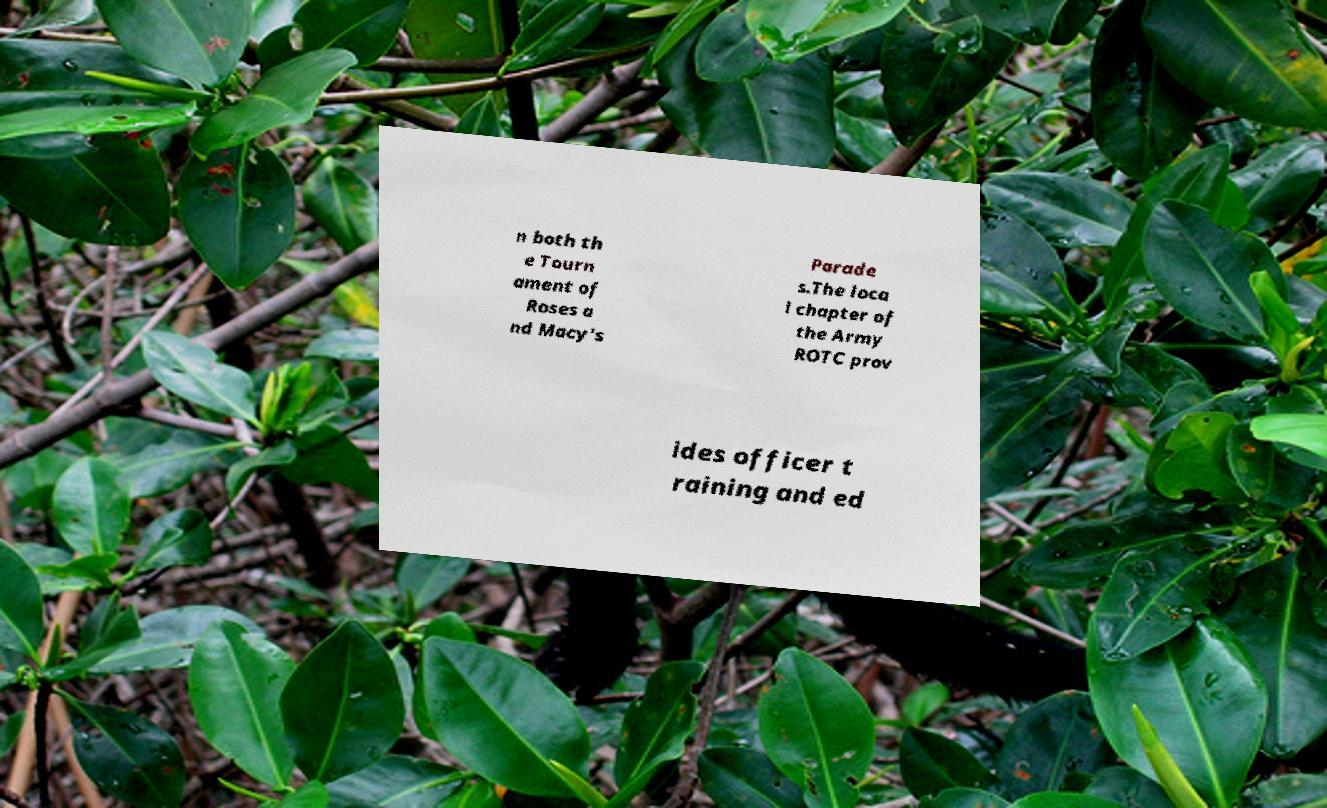Can you read and provide the text displayed in the image?This photo seems to have some interesting text. Can you extract and type it out for me? n both th e Tourn ament of Roses a nd Macy's Parade s.The loca l chapter of the Army ROTC prov ides officer t raining and ed 